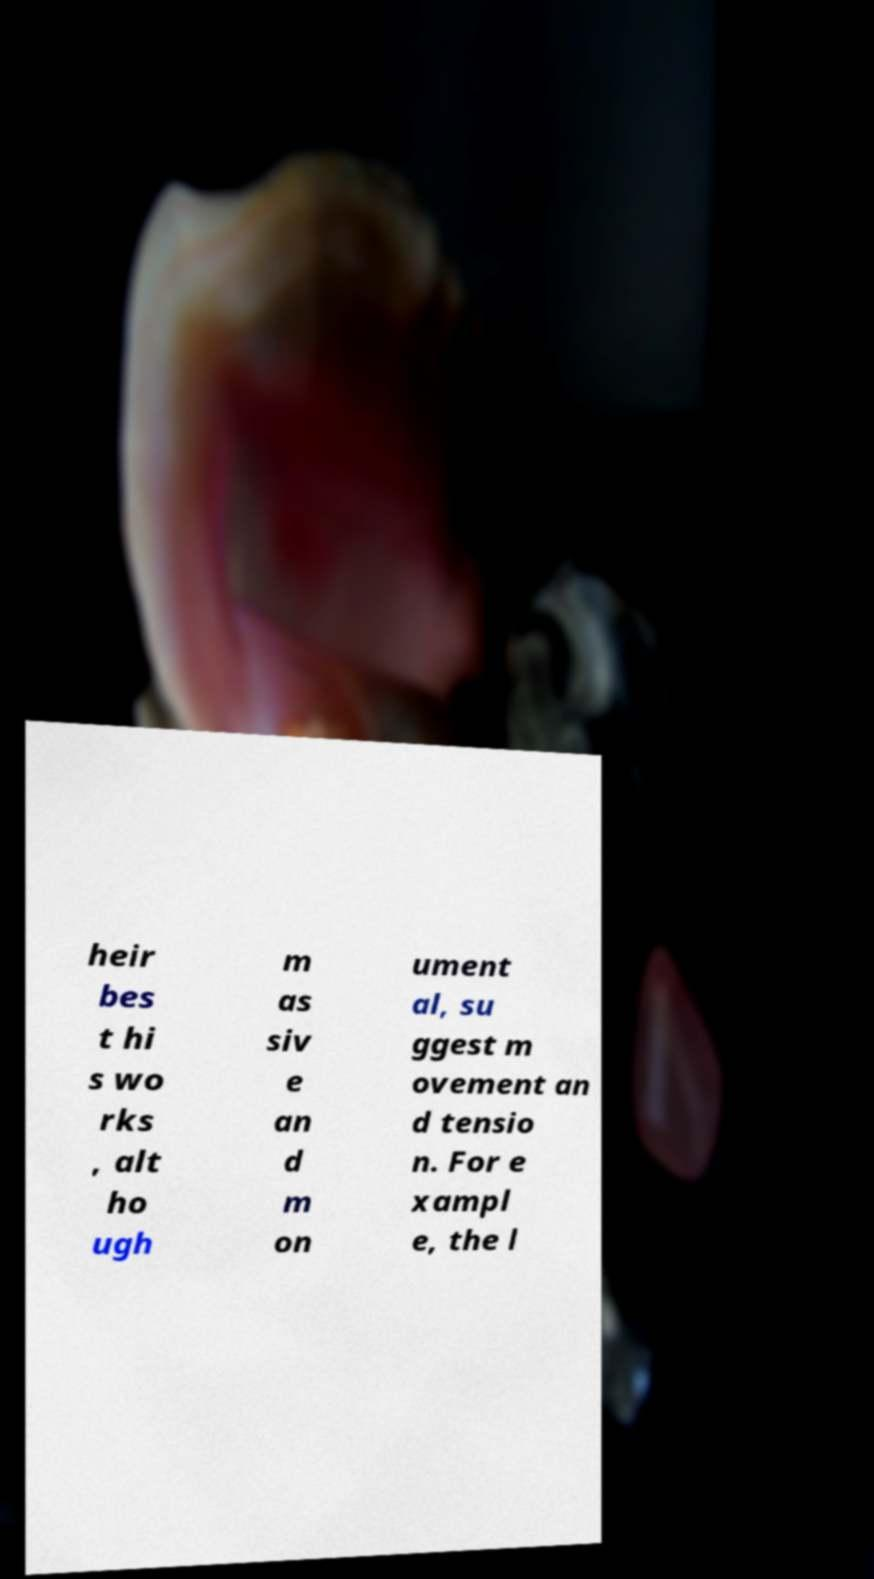For documentation purposes, I need the text within this image transcribed. Could you provide that? heir bes t hi s wo rks , alt ho ugh m as siv e an d m on ument al, su ggest m ovement an d tensio n. For e xampl e, the l 